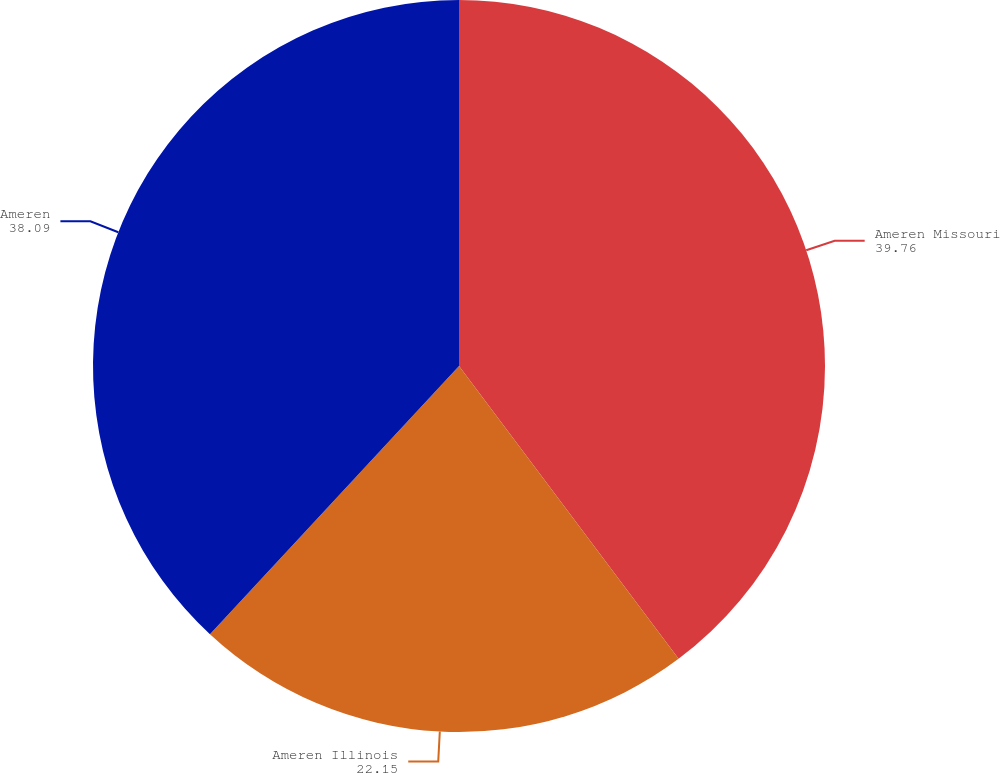Convert chart. <chart><loc_0><loc_0><loc_500><loc_500><pie_chart><fcel>Ameren Missouri<fcel>Ameren Illinois<fcel>Ameren<nl><fcel>39.76%<fcel>22.15%<fcel>38.09%<nl></chart> 